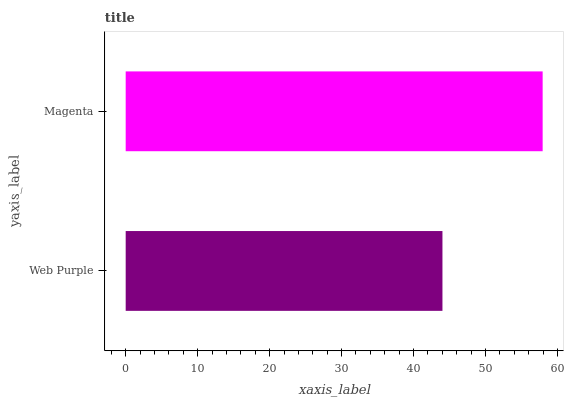Is Web Purple the minimum?
Answer yes or no. Yes. Is Magenta the maximum?
Answer yes or no. Yes. Is Magenta the minimum?
Answer yes or no. No. Is Magenta greater than Web Purple?
Answer yes or no. Yes. Is Web Purple less than Magenta?
Answer yes or no. Yes. Is Web Purple greater than Magenta?
Answer yes or no. No. Is Magenta less than Web Purple?
Answer yes or no. No. Is Magenta the high median?
Answer yes or no. Yes. Is Web Purple the low median?
Answer yes or no. Yes. Is Web Purple the high median?
Answer yes or no. No. Is Magenta the low median?
Answer yes or no. No. 